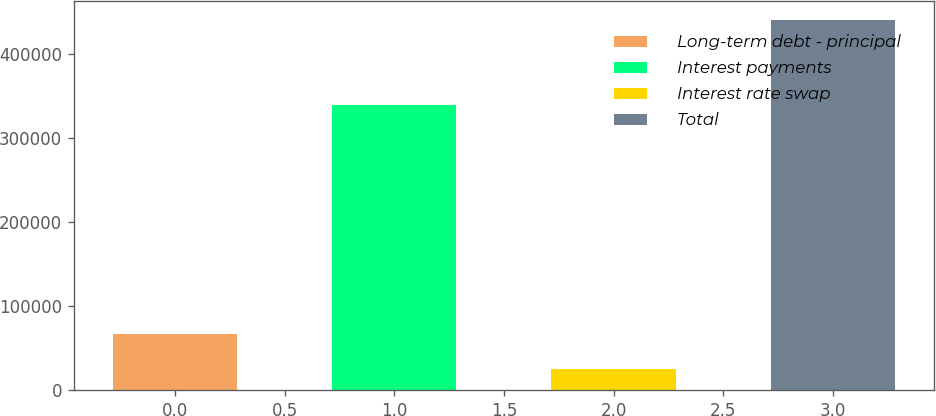Convert chart to OTSL. <chart><loc_0><loc_0><loc_500><loc_500><bar_chart><fcel>Long-term debt - principal<fcel>Interest payments<fcel>Interest rate swap<fcel>Total<nl><fcel>66114.4<fcel>339230<fcel>24522<fcel>440446<nl></chart> 